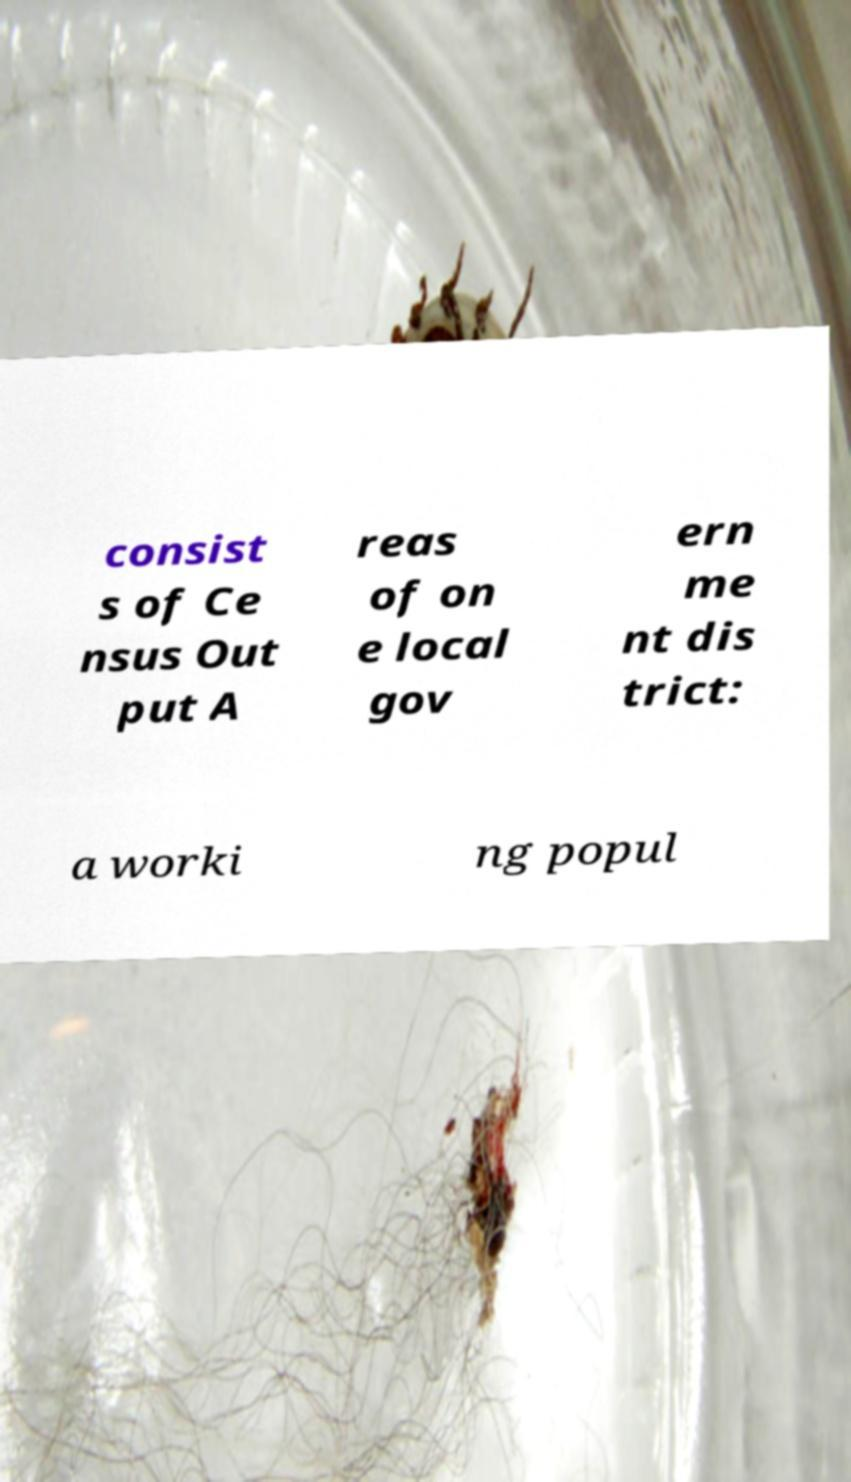I need the written content from this picture converted into text. Can you do that? consist s of Ce nsus Out put A reas of on e local gov ern me nt dis trict: a worki ng popul 